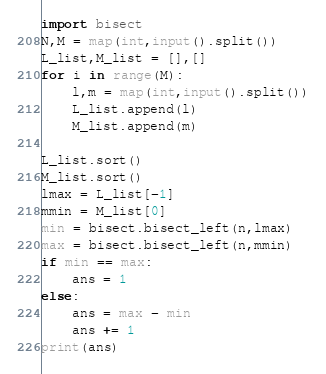Convert code to text. <code><loc_0><loc_0><loc_500><loc_500><_Python_>import bisect
N,M = map(int,input().split())
L_list,M_list = [],[]
for i in range(M):
    l,m = map(int,input().split())
    L_list.append(l)
    M_list.append(m)

L_list.sort()
M_list.sort()
lmax = L_list[-1]
mmin = M_list[0]
min = bisect.bisect_left(n,lmax)
max = bisect.bisect_left(n,mmin)
if min == max:
    ans = 1
else:
    ans = max - min
    ans += 1
print(ans)
</code> 